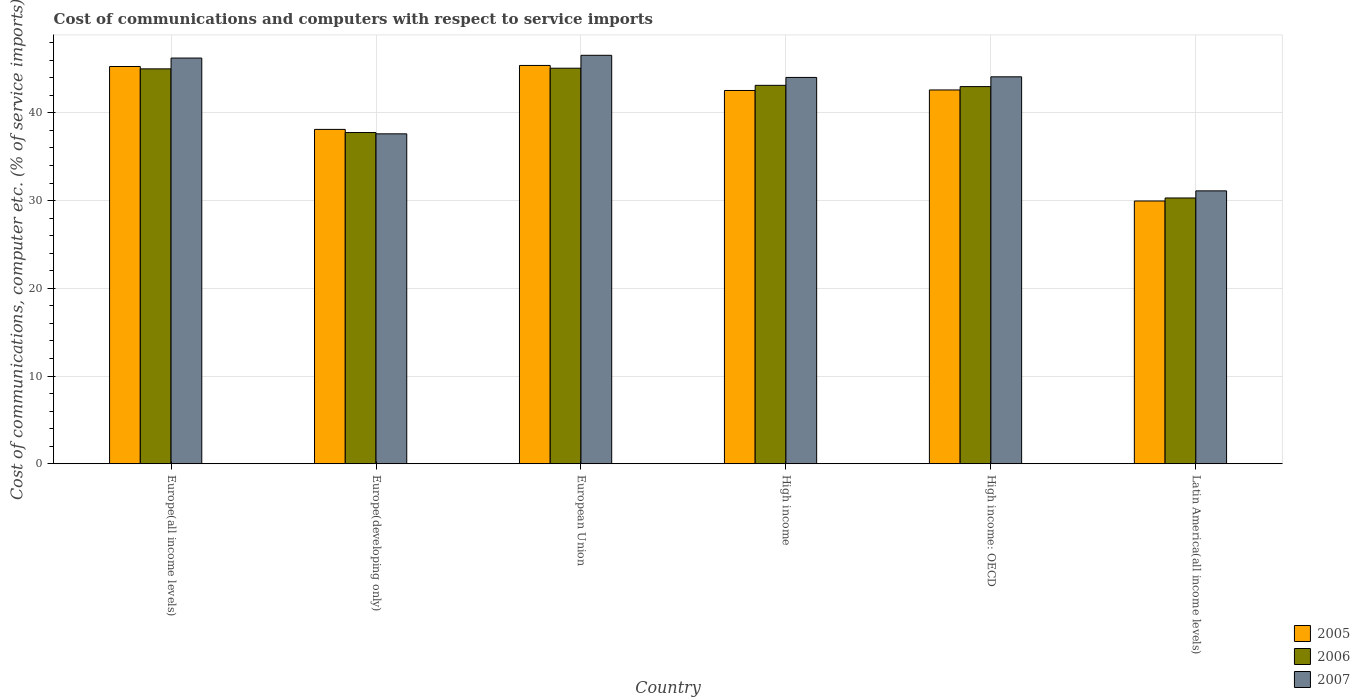How many groups of bars are there?
Provide a succinct answer. 6. How many bars are there on the 1st tick from the left?
Ensure brevity in your answer.  3. How many bars are there on the 5th tick from the right?
Your answer should be compact. 3. What is the label of the 5th group of bars from the left?
Offer a very short reply. High income: OECD. In how many cases, is the number of bars for a given country not equal to the number of legend labels?
Your answer should be compact. 0. What is the cost of communications and computers in 2007 in European Union?
Provide a short and direct response. 46.57. Across all countries, what is the maximum cost of communications and computers in 2006?
Your answer should be very brief. 45.09. Across all countries, what is the minimum cost of communications and computers in 2006?
Make the answer very short. 30.3. In which country was the cost of communications and computers in 2006 minimum?
Provide a succinct answer. Latin America(all income levels). What is the total cost of communications and computers in 2005 in the graph?
Make the answer very short. 243.94. What is the difference between the cost of communications and computers in 2006 in Europe(all income levels) and that in Latin America(all income levels)?
Make the answer very short. 14.72. What is the difference between the cost of communications and computers in 2005 in Europe(developing only) and the cost of communications and computers in 2007 in High income?
Keep it short and to the point. -5.93. What is the average cost of communications and computers in 2005 per country?
Provide a short and direct response. 40.66. What is the difference between the cost of communications and computers of/in 2006 and cost of communications and computers of/in 2007 in European Union?
Ensure brevity in your answer.  -1.47. In how many countries, is the cost of communications and computers in 2006 greater than 32 %?
Your answer should be compact. 5. What is the ratio of the cost of communications and computers in 2005 in Europe(all income levels) to that in High income: OECD?
Give a very brief answer. 1.06. Is the cost of communications and computers in 2005 in European Union less than that in Latin America(all income levels)?
Your response must be concise. No. Is the difference between the cost of communications and computers in 2006 in Europe(developing only) and High income greater than the difference between the cost of communications and computers in 2007 in Europe(developing only) and High income?
Your answer should be compact. Yes. What is the difference between the highest and the second highest cost of communications and computers in 2006?
Your answer should be very brief. -1.88. What is the difference between the highest and the lowest cost of communications and computers in 2007?
Keep it short and to the point. 15.46. Is the sum of the cost of communications and computers in 2007 in Europe(all income levels) and Latin America(all income levels) greater than the maximum cost of communications and computers in 2005 across all countries?
Offer a terse response. Yes. What does the 3rd bar from the left in High income represents?
Your answer should be compact. 2007. Is it the case that in every country, the sum of the cost of communications and computers in 2007 and cost of communications and computers in 2006 is greater than the cost of communications and computers in 2005?
Make the answer very short. Yes. Are all the bars in the graph horizontal?
Your answer should be compact. No. How many countries are there in the graph?
Your answer should be compact. 6. Are the values on the major ticks of Y-axis written in scientific E-notation?
Your answer should be very brief. No. How are the legend labels stacked?
Offer a terse response. Vertical. What is the title of the graph?
Make the answer very short. Cost of communications and computers with respect to service imports. Does "1988" appear as one of the legend labels in the graph?
Offer a very short reply. No. What is the label or title of the X-axis?
Offer a very short reply. Country. What is the label or title of the Y-axis?
Make the answer very short. Cost of communications, computer etc. (% of service imports). What is the Cost of communications, computer etc. (% of service imports) of 2005 in Europe(all income levels)?
Your answer should be compact. 45.29. What is the Cost of communications, computer etc. (% of service imports) in 2006 in Europe(all income levels)?
Keep it short and to the point. 45.02. What is the Cost of communications, computer etc. (% of service imports) in 2007 in Europe(all income levels)?
Your answer should be very brief. 46.25. What is the Cost of communications, computer etc. (% of service imports) of 2005 in Europe(developing only)?
Your answer should be compact. 38.12. What is the Cost of communications, computer etc. (% of service imports) in 2006 in Europe(developing only)?
Your answer should be very brief. 37.76. What is the Cost of communications, computer etc. (% of service imports) in 2007 in Europe(developing only)?
Offer a terse response. 37.61. What is the Cost of communications, computer etc. (% of service imports) in 2005 in European Union?
Give a very brief answer. 45.41. What is the Cost of communications, computer etc. (% of service imports) in 2006 in European Union?
Your answer should be compact. 45.09. What is the Cost of communications, computer etc. (% of service imports) of 2007 in European Union?
Ensure brevity in your answer.  46.57. What is the Cost of communications, computer etc. (% of service imports) of 2005 in High income?
Keep it short and to the point. 42.55. What is the Cost of communications, computer etc. (% of service imports) in 2006 in High income?
Your response must be concise. 43.14. What is the Cost of communications, computer etc. (% of service imports) of 2007 in High income?
Your answer should be very brief. 44.04. What is the Cost of communications, computer etc. (% of service imports) of 2005 in High income: OECD?
Offer a very short reply. 42.61. What is the Cost of communications, computer etc. (% of service imports) of 2006 in High income: OECD?
Provide a succinct answer. 43. What is the Cost of communications, computer etc. (% of service imports) in 2007 in High income: OECD?
Provide a succinct answer. 44.11. What is the Cost of communications, computer etc. (% of service imports) of 2005 in Latin America(all income levels)?
Offer a terse response. 29.95. What is the Cost of communications, computer etc. (% of service imports) in 2006 in Latin America(all income levels)?
Keep it short and to the point. 30.3. What is the Cost of communications, computer etc. (% of service imports) of 2007 in Latin America(all income levels)?
Offer a terse response. 31.11. Across all countries, what is the maximum Cost of communications, computer etc. (% of service imports) in 2005?
Your answer should be compact. 45.41. Across all countries, what is the maximum Cost of communications, computer etc. (% of service imports) in 2006?
Make the answer very short. 45.09. Across all countries, what is the maximum Cost of communications, computer etc. (% of service imports) of 2007?
Your answer should be compact. 46.57. Across all countries, what is the minimum Cost of communications, computer etc. (% of service imports) in 2005?
Provide a succinct answer. 29.95. Across all countries, what is the minimum Cost of communications, computer etc. (% of service imports) of 2006?
Your answer should be very brief. 30.3. Across all countries, what is the minimum Cost of communications, computer etc. (% of service imports) of 2007?
Keep it short and to the point. 31.11. What is the total Cost of communications, computer etc. (% of service imports) in 2005 in the graph?
Your answer should be compact. 243.94. What is the total Cost of communications, computer etc. (% of service imports) of 2006 in the graph?
Keep it short and to the point. 244.31. What is the total Cost of communications, computer etc. (% of service imports) in 2007 in the graph?
Provide a succinct answer. 249.69. What is the difference between the Cost of communications, computer etc. (% of service imports) of 2005 in Europe(all income levels) and that in Europe(developing only)?
Offer a terse response. 7.17. What is the difference between the Cost of communications, computer etc. (% of service imports) in 2006 in Europe(all income levels) and that in Europe(developing only)?
Your answer should be compact. 7.26. What is the difference between the Cost of communications, computer etc. (% of service imports) in 2007 in Europe(all income levels) and that in Europe(developing only)?
Your answer should be compact. 8.64. What is the difference between the Cost of communications, computer etc. (% of service imports) in 2005 in Europe(all income levels) and that in European Union?
Give a very brief answer. -0.12. What is the difference between the Cost of communications, computer etc. (% of service imports) in 2006 in Europe(all income levels) and that in European Union?
Offer a terse response. -0.08. What is the difference between the Cost of communications, computer etc. (% of service imports) of 2007 in Europe(all income levels) and that in European Union?
Your answer should be compact. -0.31. What is the difference between the Cost of communications, computer etc. (% of service imports) in 2005 in Europe(all income levels) and that in High income?
Provide a succinct answer. 2.73. What is the difference between the Cost of communications, computer etc. (% of service imports) of 2006 in Europe(all income levels) and that in High income?
Your answer should be very brief. 1.88. What is the difference between the Cost of communications, computer etc. (% of service imports) of 2007 in Europe(all income levels) and that in High income?
Your answer should be very brief. 2.21. What is the difference between the Cost of communications, computer etc. (% of service imports) of 2005 in Europe(all income levels) and that in High income: OECD?
Your response must be concise. 2.67. What is the difference between the Cost of communications, computer etc. (% of service imports) in 2006 in Europe(all income levels) and that in High income: OECD?
Provide a succinct answer. 2.02. What is the difference between the Cost of communications, computer etc. (% of service imports) in 2007 in Europe(all income levels) and that in High income: OECD?
Your response must be concise. 2.14. What is the difference between the Cost of communications, computer etc. (% of service imports) of 2005 in Europe(all income levels) and that in Latin America(all income levels)?
Ensure brevity in your answer.  15.33. What is the difference between the Cost of communications, computer etc. (% of service imports) in 2006 in Europe(all income levels) and that in Latin America(all income levels)?
Keep it short and to the point. 14.72. What is the difference between the Cost of communications, computer etc. (% of service imports) of 2007 in Europe(all income levels) and that in Latin America(all income levels)?
Offer a very short reply. 15.14. What is the difference between the Cost of communications, computer etc. (% of service imports) in 2005 in Europe(developing only) and that in European Union?
Your response must be concise. -7.29. What is the difference between the Cost of communications, computer etc. (% of service imports) of 2006 in Europe(developing only) and that in European Union?
Make the answer very short. -7.33. What is the difference between the Cost of communications, computer etc. (% of service imports) of 2007 in Europe(developing only) and that in European Union?
Your response must be concise. -8.95. What is the difference between the Cost of communications, computer etc. (% of service imports) in 2005 in Europe(developing only) and that in High income?
Offer a terse response. -4.44. What is the difference between the Cost of communications, computer etc. (% of service imports) in 2006 in Europe(developing only) and that in High income?
Make the answer very short. -5.38. What is the difference between the Cost of communications, computer etc. (% of service imports) in 2007 in Europe(developing only) and that in High income?
Provide a succinct answer. -6.43. What is the difference between the Cost of communications, computer etc. (% of service imports) of 2005 in Europe(developing only) and that in High income: OECD?
Give a very brief answer. -4.5. What is the difference between the Cost of communications, computer etc. (% of service imports) of 2006 in Europe(developing only) and that in High income: OECD?
Give a very brief answer. -5.24. What is the difference between the Cost of communications, computer etc. (% of service imports) in 2007 in Europe(developing only) and that in High income: OECD?
Your answer should be compact. -6.5. What is the difference between the Cost of communications, computer etc. (% of service imports) of 2005 in Europe(developing only) and that in Latin America(all income levels)?
Give a very brief answer. 8.16. What is the difference between the Cost of communications, computer etc. (% of service imports) in 2006 in Europe(developing only) and that in Latin America(all income levels)?
Give a very brief answer. 7.46. What is the difference between the Cost of communications, computer etc. (% of service imports) in 2007 in Europe(developing only) and that in Latin America(all income levels)?
Your answer should be very brief. 6.5. What is the difference between the Cost of communications, computer etc. (% of service imports) in 2005 in European Union and that in High income?
Keep it short and to the point. 2.85. What is the difference between the Cost of communications, computer etc. (% of service imports) in 2006 in European Union and that in High income?
Offer a terse response. 1.95. What is the difference between the Cost of communications, computer etc. (% of service imports) in 2007 in European Union and that in High income?
Give a very brief answer. 2.52. What is the difference between the Cost of communications, computer etc. (% of service imports) of 2005 in European Union and that in High income: OECD?
Ensure brevity in your answer.  2.79. What is the difference between the Cost of communications, computer etc. (% of service imports) in 2006 in European Union and that in High income: OECD?
Provide a succinct answer. 2.1. What is the difference between the Cost of communications, computer etc. (% of service imports) in 2007 in European Union and that in High income: OECD?
Your answer should be compact. 2.45. What is the difference between the Cost of communications, computer etc. (% of service imports) of 2005 in European Union and that in Latin America(all income levels)?
Provide a short and direct response. 15.45. What is the difference between the Cost of communications, computer etc. (% of service imports) of 2006 in European Union and that in Latin America(all income levels)?
Make the answer very short. 14.79. What is the difference between the Cost of communications, computer etc. (% of service imports) of 2007 in European Union and that in Latin America(all income levels)?
Provide a succinct answer. 15.46. What is the difference between the Cost of communications, computer etc. (% of service imports) of 2005 in High income and that in High income: OECD?
Make the answer very short. -0.06. What is the difference between the Cost of communications, computer etc. (% of service imports) in 2006 in High income and that in High income: OECD?
Your answer should be very brief. 0.14. What is the difference between the Cost of communications, computer etc. (% of service imports) of 2007 in High income and that in High income: OECD?
Give a very brief answer. -0.07. What is the difference between the Cost of communications, computer etc. (% of service imports) in 2006 in High income and that in Latin America(all income levels)?
Offer a very short reply. 12.84. What is the difference between the Cost of communications, computer etc. (% of service imports) in 2007 in High income and that in Latin America(all income levels)?
Your answer should be compact. 12.93. What is the difference between the Cost of communications, computer etc. (% of service imports) of 2005 in High income: OECD and that in Latin America(all income levels)?
Your response must be concise. 12.66. What is the difference between the Cost of communications, computer etc. (% of service imports) of 2006 in High income: OECD and that in Latin America(all income levels)?
Give a very brief answer. 12.7. What is the difference between the Cost of communications, computer etc. (% of service imports) in 2007 in High income: OECD and that in Latin America(all income levels)?
Give a very brief answer. 13. What is the difference between the Cost of communications, computer etc. (% of service imports) in 2005 in Europe(all income levels) and the Cost of communications, computer etc. (% of service imports) in 2006 in Europe(developing only)?
Keep it short and to the point. 7.53. What is the difference between the Cost of communications, computer etc. (% of service imports) in 2005 in Europe(all income levels) and the Cost of communications, computer etc. (% of service imports) in 2007 in Europe(developing only)?
Your answer should be compact. 7.68. What is the difference between the Cost of communications, computer etc. (% of service imports) of 2006 in Europe(all income levels) and the Cost of communications, computer etc. (% of service imports) of 2007 in Europe(developing only)?
Keep it short and to the point. 7.41. What is the difference between the Cost of communications, computer etc. (% of service imports) in 2005 in Europe(all income levels) and the Cost of communications, computer etc. (% of service imports) in 2006 in European Union?
Provide a short and direct response. 0.19. What is the difference between the Cost of communications, computer etc. (% of service imports) in 2005 in Europe(all income levels) and the Cost of communications, computer etc. (% of service imports) in 2007 in European Union?
Keep it short and to the point. -1.28. What is the difference between the Cost of communications, computer etc. (% of service imports) in 2006 in Europe(all income levels) and the Cost of communications, computer etc. (% of service imports) in 2007 in European Union?
Provide a succinct answer. -1.55. What is the difference between the Cost of communications, computer etc. (% of service imports) of 2005 in Europe(all income levels) and the Cost of communications, computer etc. (% of service imports) of 2006 in High income?
Give a very brief answer. 2.15. What is the difference between the Cost of communications, computer etc. (% of service imports) in 2005 in Europe(all income levels) and the Cost of communications, computer etc. (% of service imports) in 2007 in High income?
Your answer should be compact. 1.25. What is the difference between the Cost of communications, computer etc. (% of service imports) of 2006 in Europe(all income levels) and the Cost of communications, computer etc. (% of service imports) of 2007 in High income?
Offer a terse response. 0.97. What is the difference between the Cost of communications, computer etc. (% of service imports) in 2005 in Europe(all income levels) and the Cost of communications, computer etc. (% of service imports) in 2006 in High income: OECD?
Offer a terse response. 2.29. What is the difference between the Cost of communications, computer etc. (% of service imports) in 2005 in Europe(all income levels) and the Cost of communications, computer etc. (% of service imports) in 2007 in High income: OECD?
Make the answer very short. 1.18. What is the difference between the Cost of communications, computer etc. (% of service imports) of 2006 in Europe(all income levels) and the Cost of communications, computer etc. (% of service imports) of 2007 in High income: OECD?
Provide a succinct answer. 0.91. What is the difference between the Cost of communications, computer etc. (% of service imports) in 2005 in Europe(all income levels) and the Cost of communications, computer etc. (% of service imports) in 2006 in Latin America(all income levels)?
Give a very brief answer. 14.99. What is the difference between the Cost of communications, computer etc. (% of service imports) in 2005 in Europe(all income levels) and the Cost of communications, computer etc. (% of service imports) in 2007 in Latin America(all income levels)?
Offer a very short reply. 14.18. What is the difference between the Cost of communications, computer etc. (% of service imports) in 2006 in Europe(all income levels) and the Cost of communications, computer etc. (% of service imports) in 2007 in Latin America(all income levels)?
Your answer should be very brief. 13.91. What is the difference between the Cost of communications, computer etc. (% of service imports) of 2005 in Europe(developing only) and the Cost of communications, computer etc. (% of service imports) of 2006 in European Union?
Provide a succinct answer. -6.98. What is the difference between the Cost of communications, computer etc. (% of service imports) of 2005 in Europe(developing only) and the Cost of communications, computer etc. (% of service imports) of 2007 in European Union?
Offer a very short reply. -8.45. What is the difference between the Cost of communications, computer etc. (% of service imports) of 2006 in Europe(developing only) and the Cost of communications, computer etc. (% of service imports) of 2007 in European Union?
Ensure brevity in your answer.  -8.81. What is the difference between the Cost of communications, computer etc. (% of service imports) of 2005 in Europe(developing only) and the Cost of communications, computer etc. (% of service imports) of 2006 in High income?
Give a very brief answer. -5.02. What is the difference between the Cost of communications, computer etc. (% of service imports) in 2005 in Europe(developing only) and the Cost of communications, computer etc. (% of service imports) in 2007 in High income?
Keep it short and to the point. -5.93. What is the difference between the Cost of communications, computer etc. (% of service imports) of 2006 in Europe(developing only) and the Cost of communications, computer etc. (% of service imports) of 2007 in High income?
Give a very brief answer. -6.28. What is the difference between the Cost of communications, computer etc. (% of service imports) in 2005 in Europe(developing only) and the Cost of communications, computer etc. (% of service imports) in 2006 in High income: OECD?
Give a very brief answer. -4.88. What is the difference between the Cost of communications, computer etc. (% of service imports) in 2005 in Europe(developing only) and the Cost of communications, computer etc. (% of service imports) in 2007 in High income: OECD?
Give a very brief answer. -5.99. What is the difference between the Cost of communications, computer etc. (% of service imports) of 2006 in Europe(developing only) and the Cost of communications, computer etc. (% of service imports) of 2007 in High income: OECD?
Your answer should be very brief. -6.35. What is the difference between the Cost of communications, computer etc. (% of service imports) of 2005 in Europe(developing only) and the Cost of communications, computer etc. (% of service imports) of 2006 in Latin America(all income levels)?
Provide a succinct answer. 7.82. What is the difference between the Cost of communications, computer etc. (% of service imports) in 2005 in Europe(developing only) and the Cost of communications, computer etc. (% of service imports) in 2007 in Latin America(all income levels)?
Offer a very short reply. 7.01. What is the difference between the Cost of communications, computer etc. (% of service imports) in 2006 in Europe(developing only) and the Cost of communications, computer etc. (% of service imports) in 2007 in Latin America(all income levels)?
Give a very brief answer. 6.65. What is the difference between the Cost of communications, computer etc. (% of service imports) of 2005 in European Union and the Cost of communications, computer etc. (% of service imports) of 2006 in High income?
Provide a short and direct response. 2.27. What is the difference between the Cost of communications, computer etc. (% of service imports) in 2005 in European Union and the Cost of communications, computer etc. (% of service imports) in 2007 in High income?
Your answer should be compact. 1.37. What is the difference between the Cost of communications, computer etc. (% of service imports) in 2006 in European Union and the Cost of communications, computer etc. (% of service imports) in 2007 in High income?
Your response must be concise. 1.05. What is the difference between the Cost of communications, computer etc. (% of service imports) in 2005 in European Union and the Cost of communications, computer etc. (% of service imports) in 2006 in High income: OECD?
Your answer should be compact. 2.41. What is the difference between the Cost of communications, computer etc. (% of service imports) of 2005 in European Union and the Cost of communications, computer etc. (% of service imports) of 2007 in High income: OECD?
Keep it short and to the point. 1.3. What is the difference between the Cost of communications, computer etc. (% of service imports) of 2006 in European Union and the Cost of communications, computer etc. (% of service imports) of 2007 in High income: OECD?
Your response must be concise. 0.98. What is the difference between the Cost of communications, computer etc. (% of service imports) of 2005 in European Union and the Cost of communications, computer etc. (% of service imports) of 2006 in Latin America(all income levels)?
Your response must be concise. 15.11. What is the difference between the Cost of communications, computer etc. (% of service imports) of 2005 in European Union and the Cost of communications, computer etc. (% of service imports) of 2007 in Latin America(all income levels)?
Offer a very short reply. 14.3. What is the difference between the Cost of communications, computer etc. (% of service imports) in 2006 in European Union and the Cost of communications, computer etc. (% of service imports) in 2007 in Latin America(all income levels)?
Provide a short and direct response. 13.98. What is the difference between the Cost of communications, computer etc. (% of service imports) in 2005 in High income and the Cost of communications, computer etc. (% of service imports) in 2006 in High income: OECD?
Your response must be concise. -0.44. What is the difference between the Cost of communications, computer etc. (% of service imports) in 2005 in High income and the Cost of communications, computer etc. (% of service imports) in 2007 in High income: OECD?
Your answer should be very brief. -1.56. What is the difference between the Cost of communications, computer etc. (% of service imports) of 2006 in High income and the Cost of communications, computer etc. (% of service imports) of 2007 in High income: OECD?
Offer a very short reply. -0.97. What is the difference between the Cost of communications, computer etc. (% of service imports) of 2005 in High income and the Cost of communications, computer etc. (% of service imports) of 2006 in Latin America(all income levels)?
Your response must be concise. 12.25. What is the difference between the Cost of communications, computer etc. (% of service imports) of 2005 in High income and the Cost of communications, computer etc. (% of service imports) of 2007 in Latin America(all income levels)?
Offer a very short reply. 11.44. What is the difference between the Cost of communications, computer etc. (% of service imports) in 2006 in High income and the Cost of communications, computer etc. (% of service imports) in 2007 in Latin America(all income levels)?
Your response must be concise. 12.03. What is the difference between the Cost of communications, computer etc. (% of service imports) of 2005 in High income: OECD and the Cost of communications, computer etc. (% of service imports) of 2006 in Latin America(all income levels)?
Give a very brief answer. 12.31. What is the difference between the Cost of communications, computer etc. (% of service imports) of 2005 in High income: OECD and the Cost of communications, computer etc. (% of service imports) of 2007 in Latin America(all income levels)?
Give a very brief answer. 11.5. What is the difference between the Cost of communications, computer etc. (% of service imports) of 2006 in High income: OECD and the Cost of communications, computer etc. (% of service imports) of 2007 in Latin America(all income levels)?
Offer a very short reply. 11.89. What is the average Cost of communications, computer etc. (% of service imports) in 2005 per country?
Provide a short and direct response. 40.66. What is the average Cost of communications, computer etc. (% of service imports) of 2006 per country?
Ensure brevity in your answer.  40.72. What is the average Cost of communications, computer etc. (% of service imports) of 2007 per country?
Provide a short and direct response. 41.62. What is the difference between the Cost of communications, computer etc. (% of service imports) in 2005 and Cost of communications, computer etc. (% of service imports) in 2006 in Europe(all income levels)?
Give a very brief answer. 0.27. What is the difference between the Cost of communications, computer etc. (% of service imports) of 2005 and Cost of communications, computer etc. (% of service imports) of 2007 in Europe(all income levels)?
Offer a terse response. -0.96. What is the difference between the Cost of communications, computer etc. (% of service imports) of 2006 and Cost of communications, computer etc. (% of service imports) of 2007 in Europe(all income levels)?
Provide a short and direct response. -1.23. What is the difference between the Cost of communications, computer etc. (% of service imports) in 2005 and Cost of communications, computer etc. (% of service imports) in 2006 in Europe(developing only)?
Give a very brief answer. 0.36. What is the difference between the Cost of communications, computer etc. (% of service imports) of 2005 and Cost of communications, computer etc. (% of service imports) of 2007 in Europe(developing only)?
Provide a succinct answer. 0.51. What is the difference between the Cost of communications, computer etc. (% of service imports) of 2006 and Cost of communications, computer etc. (% of service imports) of 2007 in Europe(developing only)?
Ensure brevity in your answer.  0.15. What is the difference between the Cost of communications, computer etc. (% of service imports) in 2005 and Cost of communications, computer etc. (% of service imports) in 2006 in European Union?
Ensure brevity in your answer.  0.32. What is the difference between the Cost of communications, computer etc. (% of service imports) of 2005 and Cost of communications, computer etc. (% of service imports) of 2007 in European Union?
Ensure brevity in your answer.  -1.16. What is the difference between the Cost of communications, computer etc. (% of service imports) in 2006 and Cost of communications, computer etc. (% of service imports) in 2007 in European Union?
Your answer should be very brief. -1.47. What is the difference between the Cost of communications, computer etc. (% of service imports) in 2005 and Cost of communications, computer etc. (% of service imports) in 2006 in High income?
Your answer should be very brief. -0.59. What is the difference between the Cost of communications, computer etc. (% of service imports) of 2005 and Cost of communications, computer etc. (% of service imports) of 2007 in High income?
Provide a succinct answer. -1.49. What is the difference between the Cost of communications, computer etc. (% of service imports) in 2006 and Cost of communications, computer etc. (% of service imports) in 2007 in High income?
Make the answer very short. -0.9. What is the difference between the Cost of communications, computer etc. (% of service imports) in 2005 and Cost of communications, computer etc. (% of service imports) in 2006 in High income: OECD?
Provide a succinct answer. -0.38. What is the difference between the Cost of communications, computer etc. (% of service imports) in 2005 and Cost of communications, computer etc. (% of service imports) in 2007 in High income: OECD?
Provide a succinct answer. -1.5. What is the difference between the Cost of communications, computer etc. (% of service imports) of 2006 and Cost of communications, computer etc. (% of service imports) of 2007 in High income: OECD?
Ensure brevity in your answer.  -1.11. What is the difference between the Cost of communications, computer etc. (% of service imports) in 2005 and Cost of communications, computer etc. (% of service imports) in 2006 in Latin America(all income levels)?
Your answer should be compact. -0.35. What is the difference between the Cost of communications, computer etc. (% of service imports) in 2005 and Cost of communications, computer etc. (% of service imports) in 2007 in Latin America(all income levels)?
Your answer should be very brief. -1.16. What is the difference between the Cost of communications, computer etc. (% of service imports) in 2006 and Cost of communications, computer etc. (% of service imports) in 2007 in Latin America(all income levels)?
Provide a succinct answer. -0.81. What is the ratio of the Cost of communications, computer etc. (% of service imports) in 2005 in Europe(all income levels) to that in Europe(developing only)?
Give a very brief answer. 1.19. What is the ratio of the Cost of communications, computer etc. (% of service imports) in 2006 in Europe(all income levels) to that in Europe(developing only)?
Your response must be concise. 1.19. What is the ratio of the Cost of communications, computer etc. (% of service imports) in 2007 in Europe(all income levels) to that in Europe(developing only)?
Provide a short and direct response. 1.23. What is the ratio of the Cost of communications, computer etc. (% of service imports) of 2005 in Europe(all income levels) to that in European Union?
Offer a very short reply. 1. What is the ratio of the Cost of communications, computer etc. (% of service imports) of 2006 in Europe(all income levels) to that in European Union?
Keep it short and to the point. 1. What is the ratio of the Cost of communications, computer etc. (% of service imports) in 2005 in Europe(all income levels) to that in High income?
Ensure brevity in your answer.  1.06. What is the ratio of the Cost of communications, computer etc. (% of service imports) in 2006 in Europe(all income levels) to that in High income?
Offer a very short reply. 1.04. What is the ratio of the Cost of communications, computer etc. (% of service imports) in 2007 in Europe(all income levels) to that in High income?
Your response must be concise. 1.05. What is the ratio of the Cost of communications, computer etc. (% of service imports) in 2005 in Europe(all income levels) to that in High income: OECD?
Provide a succinct answer. 1.06. What is the ratio of the Cost of communications, computer etc. (% of service imports) in 2006 in Europe(all income levels) to that in High income: OECD?
Offer a terse response. 1.05. What is the ratio of the Cost of communications, computer etc. (% of service imports) of 2007 in Europe(all income levels) to that in High income: OECD?
Give a very brief answer. 1.05. What is the ratio of the Cost of communications, computer etc. (% of service imports) of 2005 in Europe(all income levels) to that in Latin America(all income levels)?
Your answer should be compact. 1.51. What is the ratio of the Cost of communications, computer etc. (% of service imports) of 2006 in Europe(all income levels) to that in Latin America(all income levels)?
Offer a very short reply. 1.49. What is the ratio of the Cost of communications, computer etc. (% of service imports) in 2007 in Europe(all income levels) to that in Latin America(all income levels)?
Your answer should be compact. 1.49. What is the ratio of the Cost of communications, computer etc. (% of service imports) in 2005 in Europe(developing only) to that in European Union?
Make the answer very short. 0.84. What is the ratio of the Cost of communications, computer etc. (% of service imports) of 2006 in Europe(developing only) to that in European Union?
Your response must be concise. 0.84. What is the ratio of the Cost of communications, computer etc. (% of service imports) of 2007 in Europe(developing only) to that in European Union?
Make the answer very short. 0.81. What is the ratio of the Cost of communications, computer etc. (% of service imports) in 2005 in Europe(developing only) to that in High income?
Keep it short and to the point. 0.9. What is the ratio of the Cost of communications, computer etc. (% of service imports) in 2006 in Europe(developing only) to that in High income?
Make the answer very short. 0.88. What is the ratio of the Cost of communications, computer etc. (% of service imports) in 2007 in Europe(developing only) to that in High income?
Offer a very short reply. 0.85. What is the ratio of the Cost of communications, computer etc. (% of service imports) in 2005 in Europe(developing only) to that in High income: OECD?
Make the answer very short. 0.89. What is the ratio of the Cost of communications, computer etc. (% of service imports) in 2006 in Europe(developing only) to that in High income: OECD?
Your answer should be compact. 0.88. What is the ratio of the Cost of communications, computer etc. (% of service imports) in 2007 in Europe(developing only) to that in High income: OECD?
Give a very brief answer. 0.85. What is the ratio of the Cost of communications, computer etc. (% of service imports) in 2005 in Europe(developing only) to that in Latin America(all income levels)?
Keep it short and to the point. 1.27. What is the ratio of the Cost of communications, computer etc. (% of service imports) of 2006 in Europe(developing only) to that in Latin America(all income levels)?
Provide a short and direct response. 1.25. What is the ratio of the Cost of communications, computer etc. (% of service imports) of 2007 in Europe(developing only) to that in Latin America(all income levels)?
Make the answer very short. 1.21. What is the ratio of the Cost of communications, computer etc. (% of service imports) in 2005 in European Union to that in High income?
Keep it short and to the point. 1.07. What is the ratio of the Cost of communications, computer etc. (% of service imports) of 2006 in European Union to that in High income?
Give a very brief answer. 1.05. What is the ratio of the Cost of communications, computer etc. (% of service imports) of 2007 in European Union to that in High income?
Make the answer very short. 1.06. What is the ratio of the Cost of communications, computer etc. (% of service imports) in 2005 in European Union to that in High income: OECD?
Your answer should be compact. 1.07. What is the ratio of the Cost of communications, computer etc. (% of service imports) of 2006 in European Union to that in High income: OECD?
Ensure brevity in your answer.  1.05. What is the ratio of the Cost of communications, computer etc. (% of service imports) in 2007 in European Union to that in High income: OECD?
Your response must be concise. 1.06. What is the ratio of the Cost of communications, computer etc. (% of service imports) in 2005 in European Union to that in Latin America(all income levels)?
Offer a terse response. 1.52. What is the ratio of the Cost of communications, computer etc. (% of service imports) of 2006 in European Union to that in Latin America(all income levels)?
Provide a succinct answer. 1.49. What is the ratio of the Cost of communications, computer etc. (% of service imports) in 2007 in European Union to that in Latin America(all income levels)?
Your answer should be compact. 1.5. What is the ratio of the Cost of communications, computer etc. (% of service imports) in 2005 in High income to that in High income: OECD?
Give a very brief answer. 1. What is the ratio of the Cost of communications, computer etc. (% of service imports) of 2006 in High income to that in High income: OECD?
Give a very brief answer. 1. What is the ratio of the Cost of communications, computer etc. (% of service imports) of 2005 in High income to that in Latin America(all income levels)?
Give a very brief answer. 1.42. What is the ratio of the Cost of communications, computer etc. (% of service imports) in 2006 in High income to that in Latin America(all income levels)?
Offer a very short reply. 1.42. What is the ratio of the Cost of communications, computer etc. (% of service imports) of 2007 in High income to that in Latin America(all income levels)?
Offer a terse response. 1.42. What is the ratio of the Cost of communications, computer etc. (% of service imports) of 2005 in High income: OECD to that in Latin America(all income levels)?
Your answer should be compact. 1.42. What is the ratio of the Cost of communications, computer etc. (% of service imports) in 2006 in High income: OECD to that in Latin America(all income levels)?
Your answer should be very brief. 1.42. What is the ratio of the Cost of communications, computer etc. (% of service imports) of 2007 in High income: OECD to that in Latin America(all income levels)?
Provide a succinct answer. 1.42. What is the difference between the highest and the second highest Cost of communications, computer etc. (% of service imports) of 2005?
Offer a very short reply. 0.12. What is the difference between the highest and the second highest Cost of communications, computer etc. (% of service imports) of 2006?
Ensure brevity in your answer.  0.08. What is the difference between the highest and the second highest Cost of communications, computer etc. (% of service imports) of 2007?
Ensure brevity in your answer.  0.31. What is the difference between the highest and the lowest Cost of communications, computer etc. (% of service imports) of 2005?
Provide a short and direct response. 15.45. What is the difference between the highest and the lowest Cost of communications, computer etc. (% of service imports) of 2006?
Keep it short and to the point. 14.79. What is the difference between the highest and the lowest Cost of communications, computer etc. (% of service imports) in 2007?
Give a very brief answer. 15.46. 